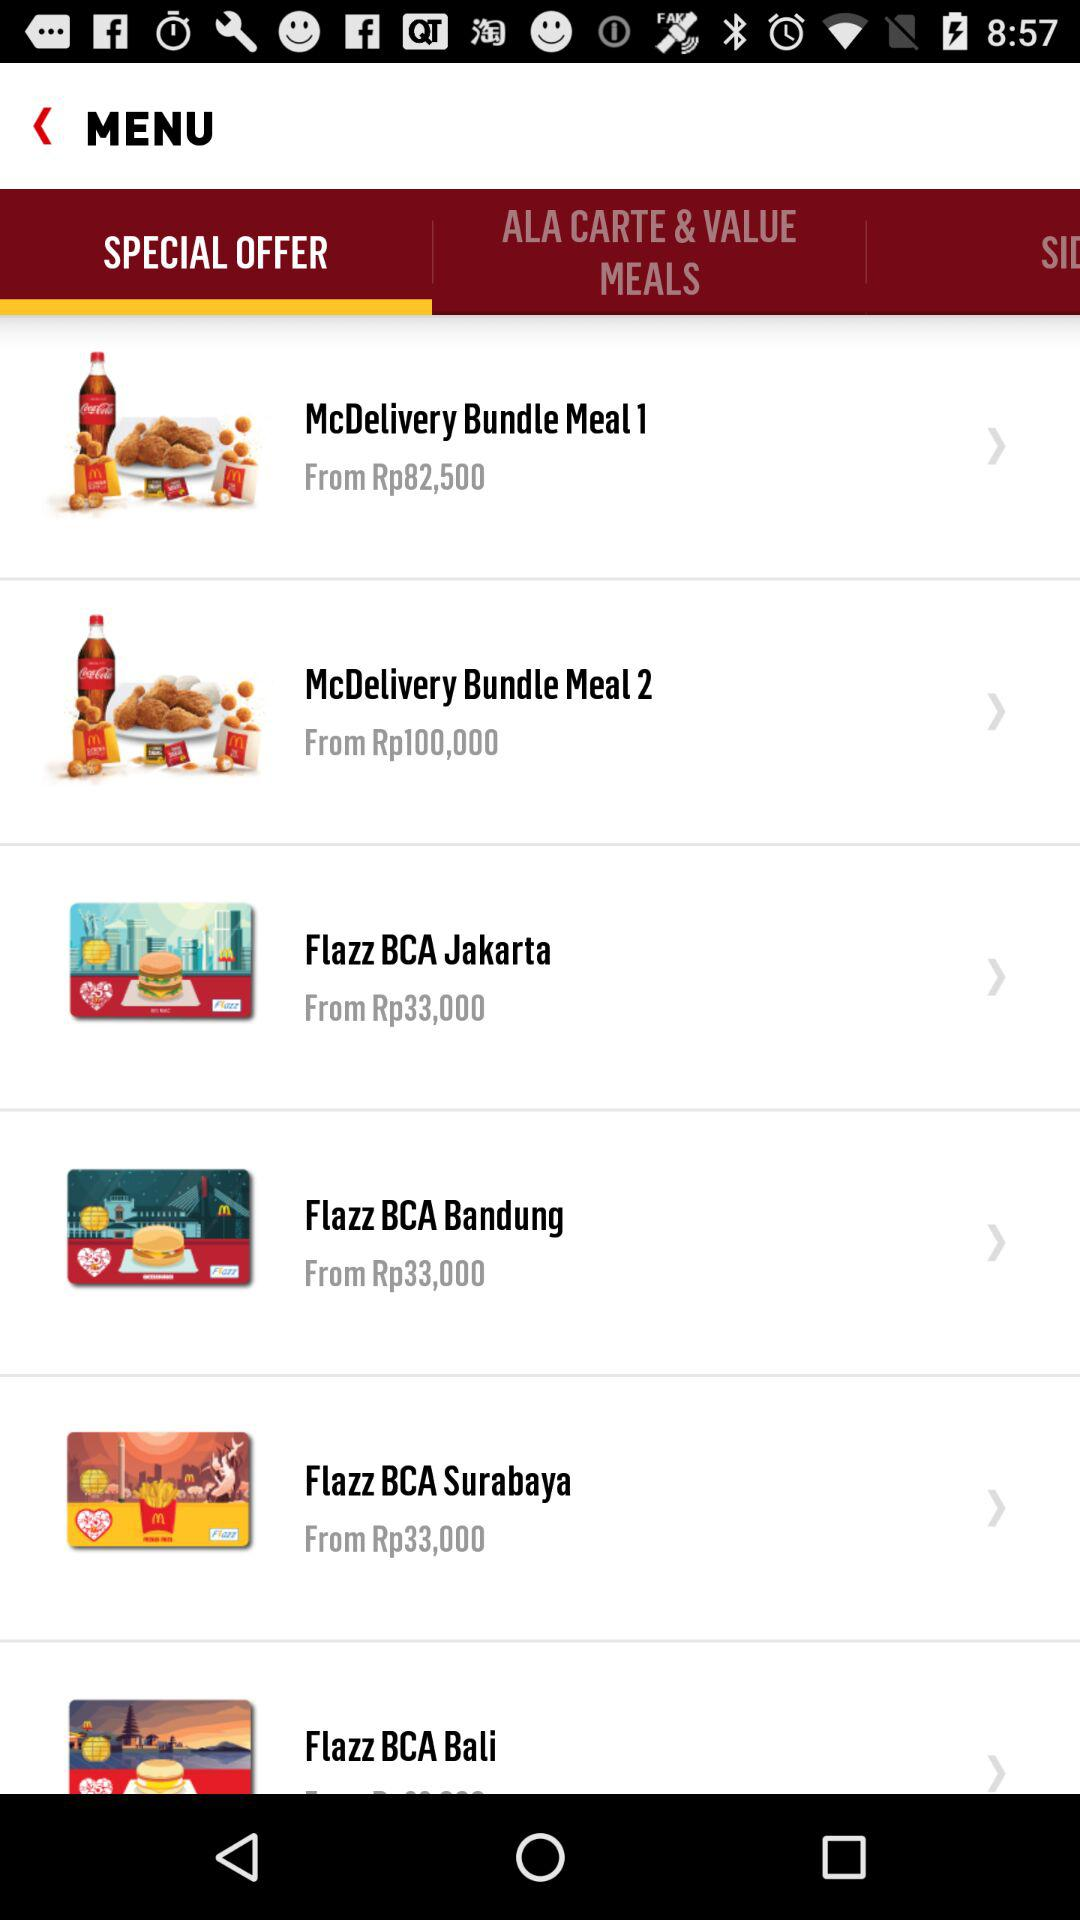What is the price of "Flazz BCA Jakarta"? The price of "Flazz BCA Jakarta" starts at Rp33,000. 